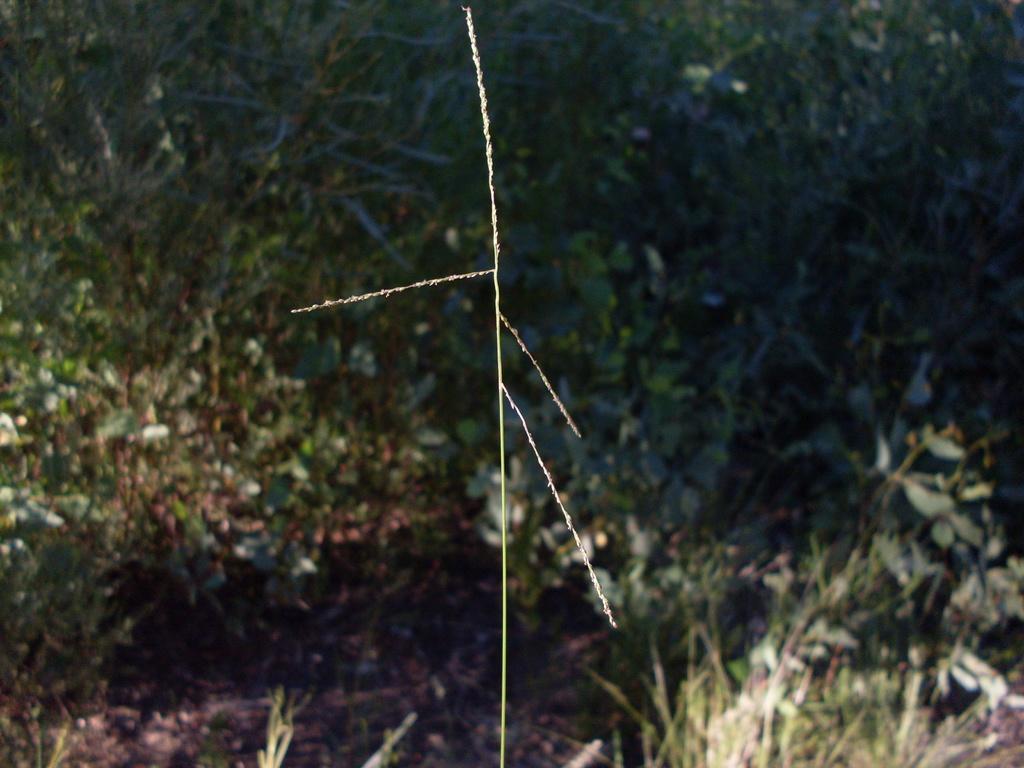Can you describe this image briefly? In this image we can see some plants and grass on the ground. 